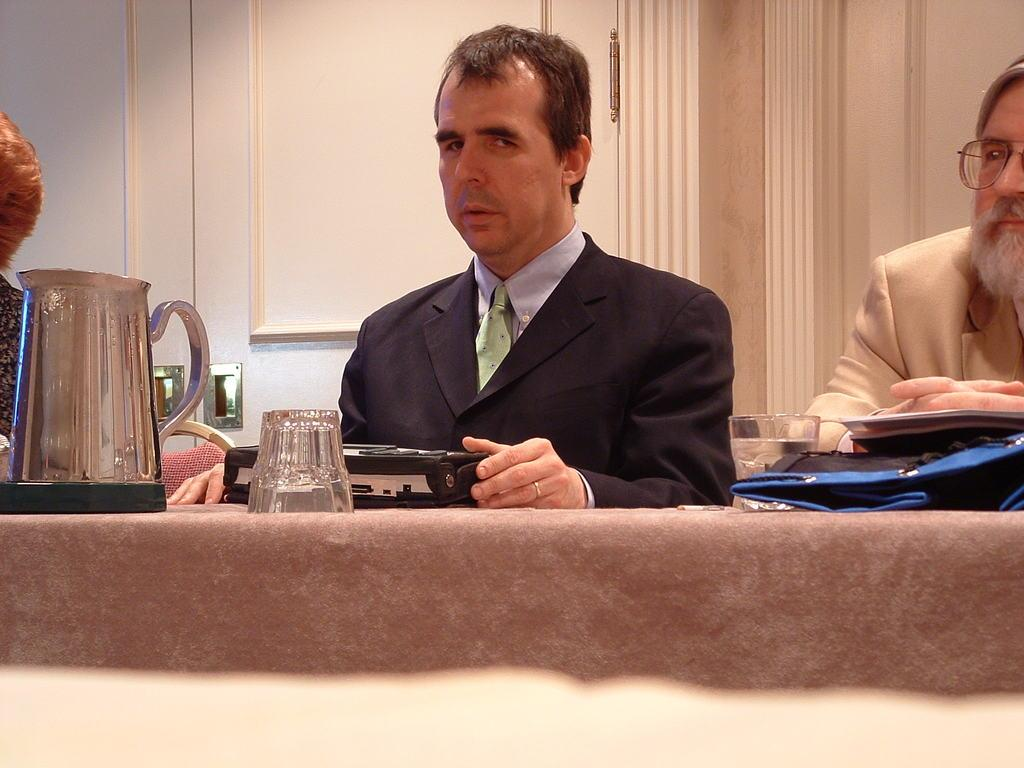What is the man in the image looking at? There is a man looking at something in the image, but the facts do not specify what he is looking at. Who is beside the man in the image? There is another man beside him. What objects are in front of the two men? There is a glass, a jar, and a device in front of them. What can be seen in the background of the image? There is a door visible in the background of the image. What type of wave is the uncle riding in the image? There is no uncle or wave present in the image. 